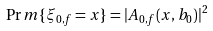Convert formula to latex. <formula><loc_0><loc_0><loc_500><loc_500>\Pr m \{ \xi _ { 0 , f } = x \} = | A _ { 0 , f } ( x , b _ { 0 } ) | ^ { 2 }</formula> 